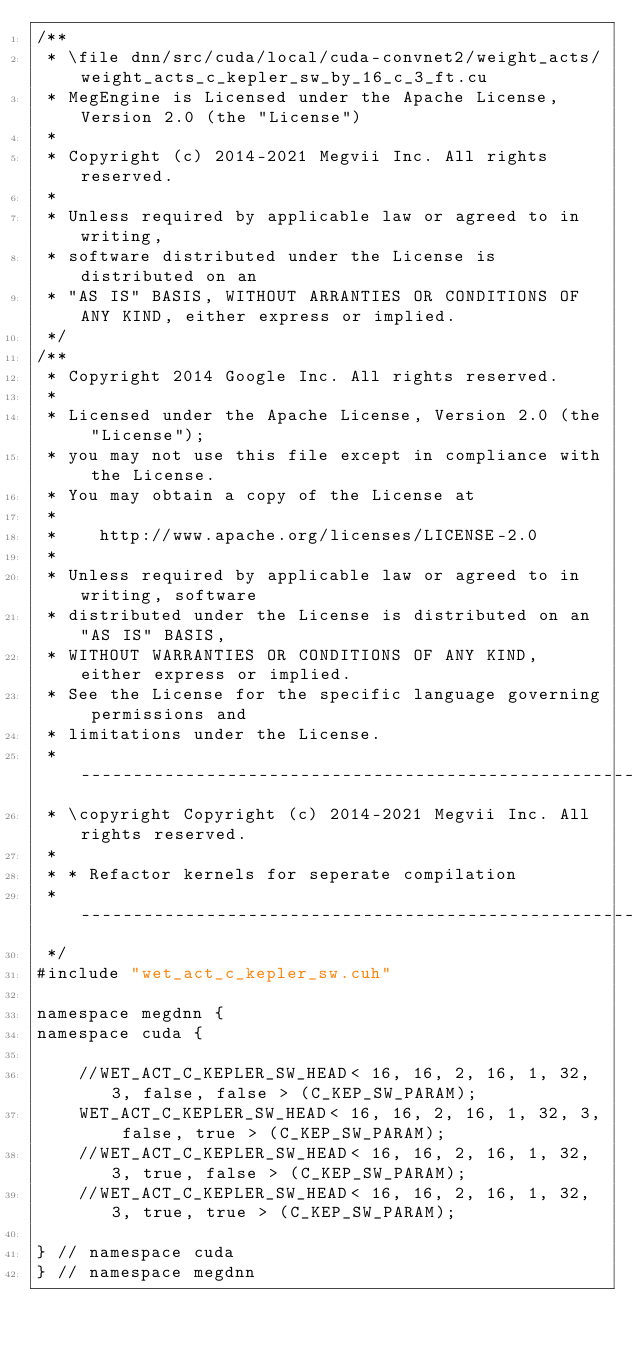<code> <loc_0><loc_0><loc_500><loc_500><_Cuda_>/**
 * \file dnn/src/cuda/local/cuda-convnet2/weight_acts/weight_acts_c_kepler_sw_by_16_c_3_ft.cu
 * MegEngine is Licensed under the Apache License, Version 2.0 (the "License")
 *
 * Copyright (c) 2014-2021 Megvii Inc. All rights reserved.
 *
 * Unless required by applicable law or agreed to in writing,
 * software distributed under the License is distributed on an
 * "AS IS" BASIS, WITHOUT ARRANTIES OR CONDITIONS OF ANY KIND, either express or implied.
 */
/**
 * Copyright 2014 Google Inc. All rights reserved.
 *
 * Licensed under the Apache License, Version 2.0 (the "License");
 * you may not use this file except in compliance with the License.
 * You may obtain a copy of the License at
 *
 *    http://www.apache.org/licenses/LICENSE-2.0
 *
 * Unless required by applicable law or agreed to in writing, software
 * distributed under the License is distributed on an "AS IS" BASIS,
 * WITHOUT WARRANTIES OR CONDITIONS OF ANY KIND, either express or implied.
 * See the License for the specific language governing permissions and
 * limitations under the License.
 * --------------------------------------------------------------------------
 * \copyright Copyright (c) 2014-2021 Megvii Inc. All rights reserved.
 *
 * * Refactor kernels for seperate compilation
 * --------------------------------------------------------------------------
 */
#include "wet_act_c_kepler_sw.cuh"

namespace megdnn {
namespace cuda {

    //WET_ACT_C_KEPLER_SW_HEAD< 16, 16, 2, 16, 1, 32, 3, false, false > (C_KEP_SW_PARAM);
    WET_ACT_C_KEPLER_SW_HEAD< 16, 16, 2, 16, 1, 32, 3, false, true > (C_KEP_SW_PARAM);
    //WET_ACT_C_KEPLER_SW_HEAD< 16, 16, 2, 16, 1, 32, 3, true, false > (C_KEP_SW_PARAM);
    //WET_ACT_C_KEPLER_SW_HEAD< 16, 16, 2, 16, 1, 32, 3, true, true > (C_KEP_SW_PARAM);

} // namespace cuda
} // namespace megdnn
</code> 